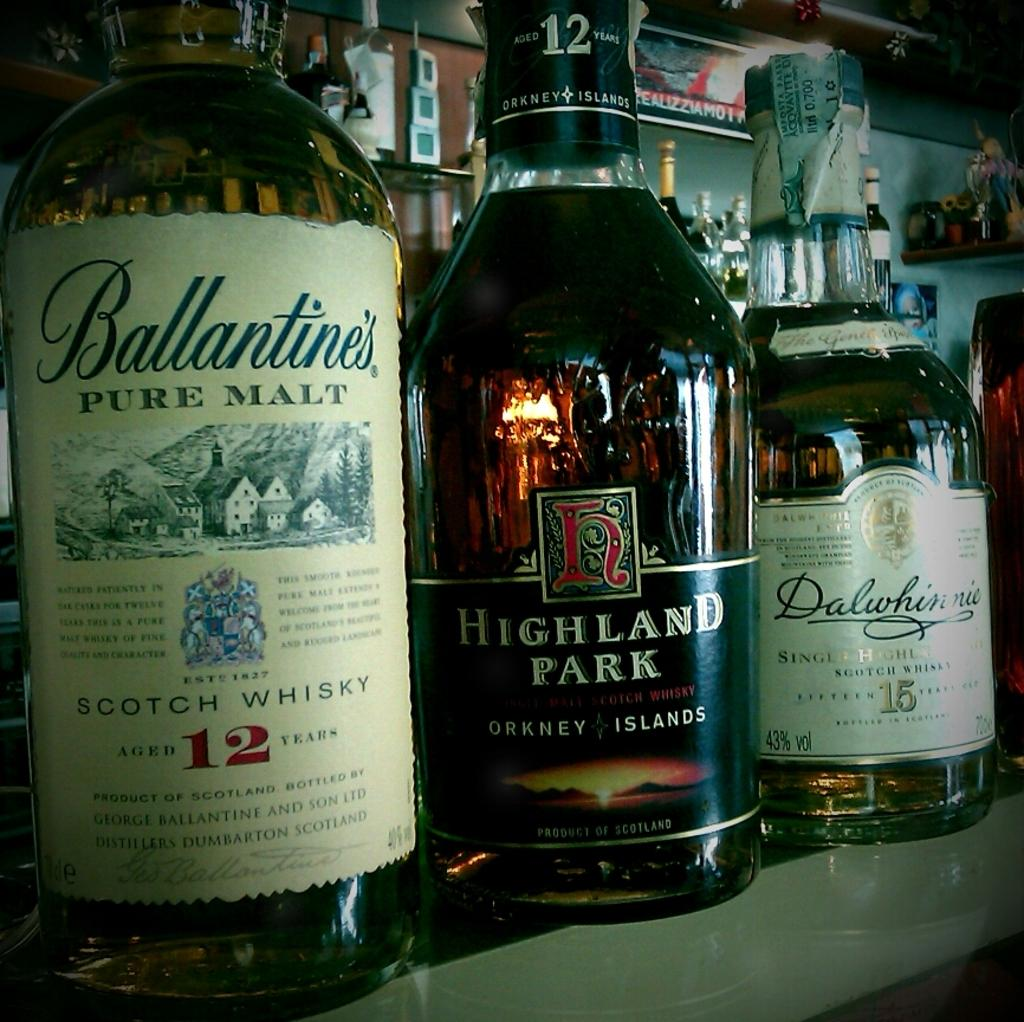<image>
Relay a brief, clear account of the picture shown. A bottle of Highland Park sits next to a bottle of Ballantine's pure malt. 